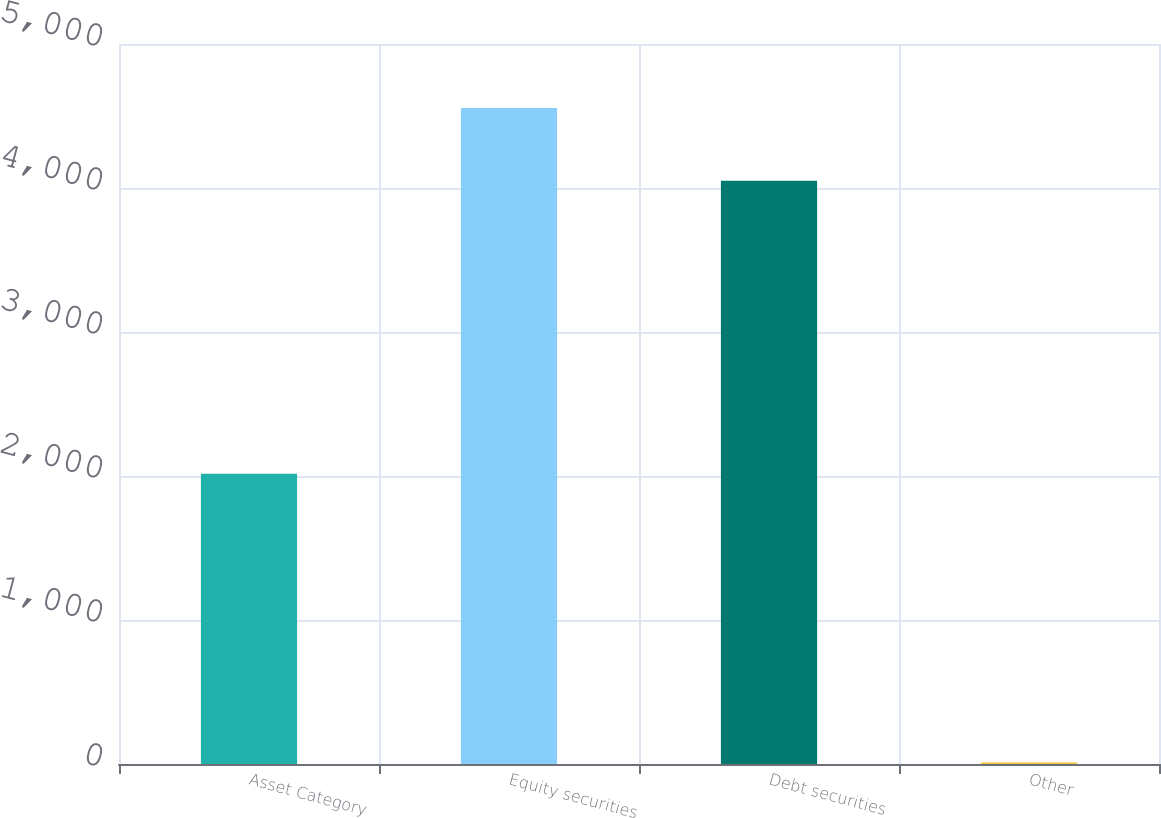Convert chart to OTSL. <chart><loc_0><loc_0><loc_500><loc_500><bar_chart><fcel>Asset Category<fcel>Equity securities<fcel>Debt securities<fcel>Other<nl><fcel>2015<fcel>4555<fcel>4050<fcel>10<nl></chart> 